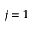<formula> <loc_0><loc_0><loc_500><loc_500>j = 1</formula> 